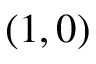Convert formula to latex. <formula><loc_0><loc_0><loc_500><loc_500>( 1 , 0 )</formula> 